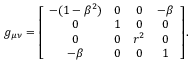<formula> <loc_0><loc_0><loc_500><loc_500>g _ { \mu \nu } = \left [ \begin{array} { c c c c } { - ( 1 - \beta ^ { 2 } ) } & { 0 } & { 0 } & { - \beta } \\ { 0 } & { 1 } & { 0 } & { 0 } \\ { 0 } & { 0 } & { r ^ { 2 } } & { 0 } \\ { - \beta } & { 0 } & { 0 } & { 1 } \end{array} \right ] .</formula> 